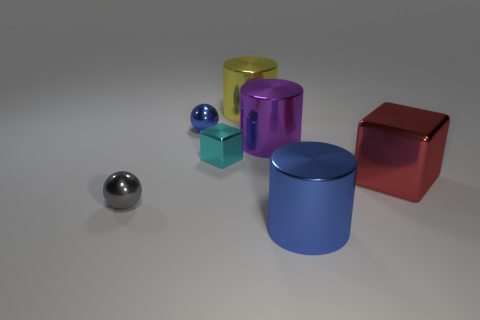Are there more tiny metal spheres behind the purple metal object than large cylinders left of the gray shiny sphere?
Ensure brevity in your answer.  Yes. What size is the blue thing behind the blue metallic object that is to the right of the cube that is to the left of the big blue shiny cylinder?
Keep it short and to the point. Small. Do the yellow object and the red shiny object have the same shape?
Give a very brief answer. No. What number of other things are made of the same material as the tiny cube?
Your answer should be very brief. 6. What number of other metal things are the same shape as the tiny gray thing?
Keep it short and to the point. 1. There is a big shiny thing that is to the left of the big shiny block and in front of the tiny cyan metal object; what is its color?
Provide a succinct answer. Blue. How many small red balls are there?
Keep it short and to the point. 0. Does the blue shiny ball have the same size as the yellow metal object?
Your answer should be very brief. No. There is a blue metal thing right of the big yellow cylinder; does it have the same shape as the big purple object?
Offer a terse response. Yes. What number of other purple cylinders have the same size as the purple metal cylinder?
Give a very brief answer. 0. 